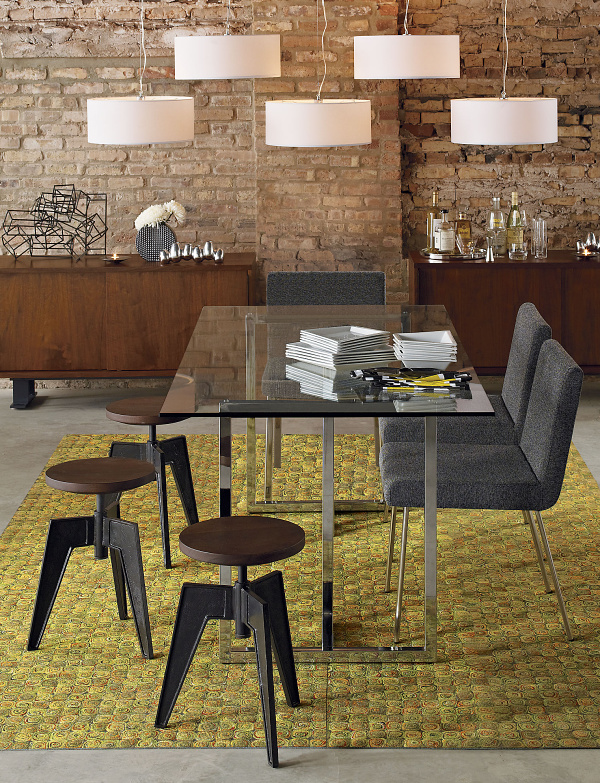Tell me about the design elements visible in the room. This room is a testament to a well-balanced blend of textures and design philosophies. The raw texture of the brick wall anchors the room with an earthy, grounded feel, while the glass dining table introduces a modern, minimalist element. The area rug under the table provides a splash of color with its intricate pattern, and the contrasting furniture materials - from the solid wooden sideboard to the metal frames of the table and stools - all add layer and depth to this design-forward interior. 